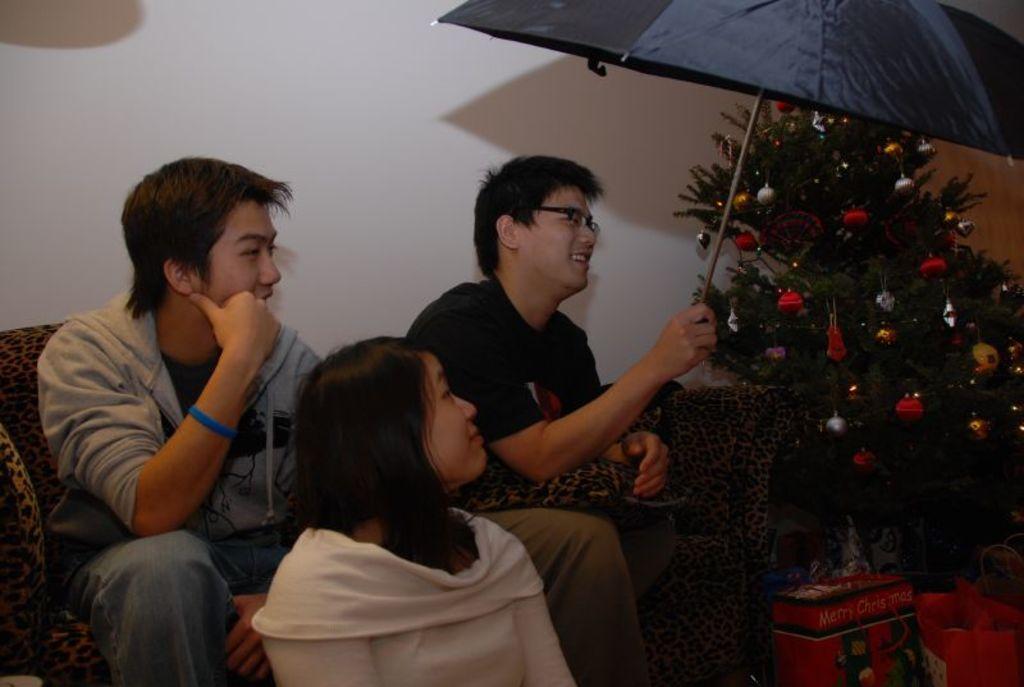Can you describe this image briefly? In this image we can see two people sitting on the sofa. At the bottom there is a lady. On the right we can see bags and an xmas tree. The man sitting in the center is holding an umbrella. In the background there is a wall. 